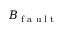Convert formula to latex. <formula><loc_0><loc_0><loc_500><loc_500>B _ { f a u l t }</formula> 